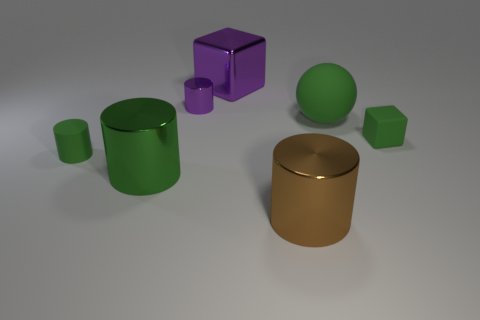What might be the use of these objects if they were real? If these objects were real, their uses could depend on the material and size. The cylinders might serve as storage containers or decorative vases, the sphere could be a decorative piece or even a large bouncy ball, and the cubes might be used as dice, stools, or artistic sculptures. The variety in size and color suggests they could complement each other in a functional and aesthetically pleasing set. 